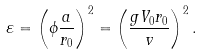<formula> <loc_0><loc_0><loc_500><loc_500>\varepsilon = \left ( \phi \frac { a } { r _ { 0 } } \right ) ^ { 2 } = \left ( \frac { g V _ { 0 } r _ { 0 } } { { } v } \right ) ^ { 2 } .</formula> 